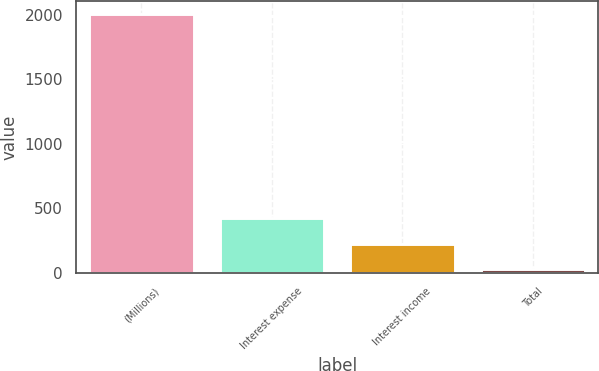<chart> <loc_0><loc_0><loc_500><loc_500><bar_chart><fcel>(Millions)<fcel>Interest expense<fcel>Interest income<fcel>Total<nl><fcel>2005<fcel>421.8<fcel>223.9<fcel>26<nl></chart> 